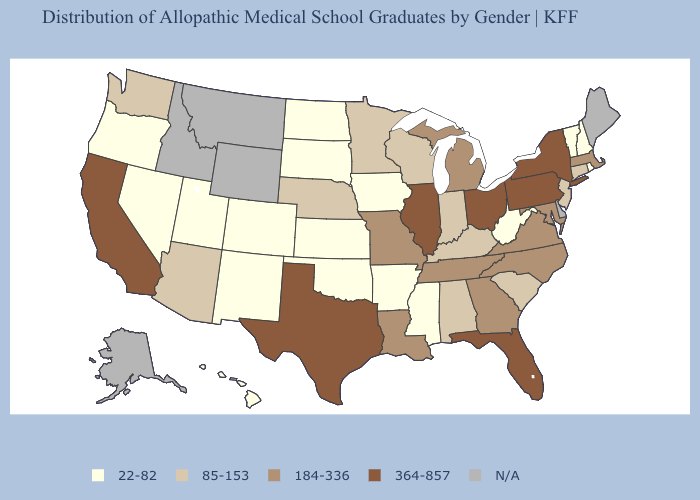Does New York have the highest value in the USA?
Quick response, please. Yes. What is the lowest value in the West?
Concise answer only. 22-82. What is the highest value in the USA?
Quick response, please. 364-857. Is the legend a continuous bar?
Short answer required. No. Does the map have missing data?
Quick response, please. Yes. What is the value of Kentucky?
Answer briefly. 85-153. Is the legend a continuous bar?
Keep it brief. No. What is the highest value in the USA?
Concise answer only. 364-857. Among the states that border Ohio , does West Virginia have the highest value?
Answer briefly. No. Does South Dakota have the lowest value in the USA?
Concise answer only. Yes. 